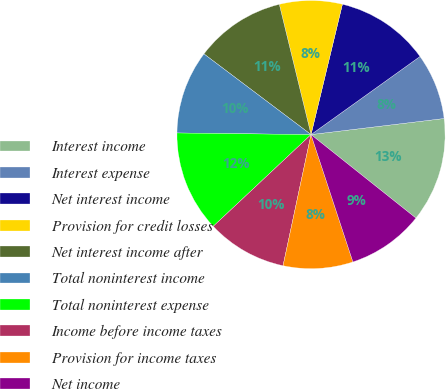Convert chart. <chart><loc_0><loc_0><loc_500><loc_500><pie_chart><fcel>Interest income<fcel>Interest expense<fcel>Net interest income<fcel>Provision for credit losses<fcel>Net interest income after<fcel>Total noninterest income<fcel>Total noninterest expense<fcel>Income before income taxes<fcel>Provision for income taxes<fcel>Net income<nl><fcel>12.61%<fcel>7.98%<fcel>11.34%<fcel>7.56%<fcel>10.92%<fcel>10.08%<fcel>12.18%<fcel>9.66%<fcel>8.4%<fcel>9.24%<nl></chart> 